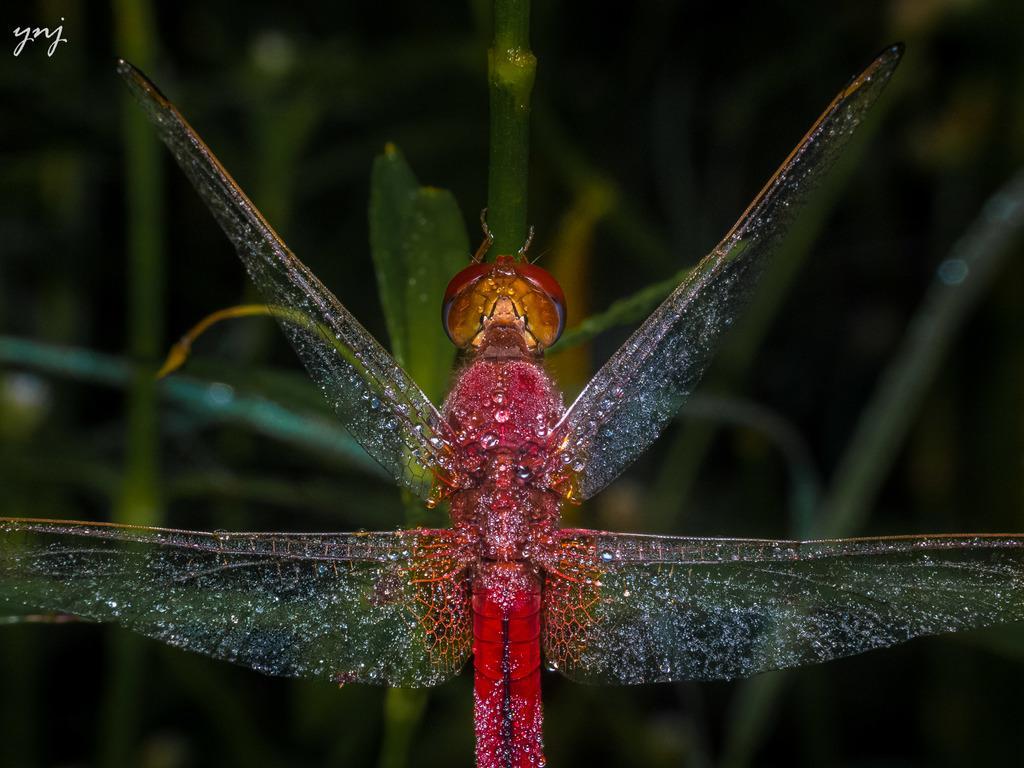In one or two sentences, can you explain what this image depicts? In this image in the front there is an insect sitting on the leaf and the background is blurry. 